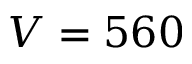Convert formula to latex. <formula><loc_0><loc_0><loc_500><loc_500>V = 5 6 0</formula> 